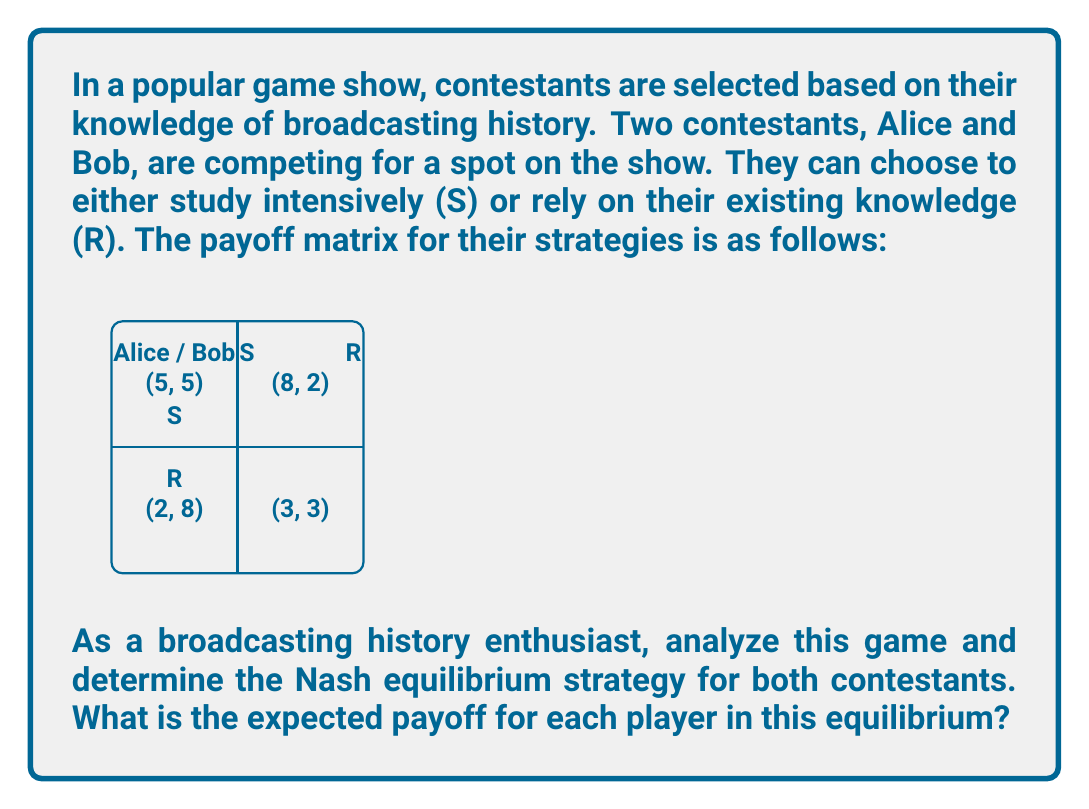Can you answer this question? To find the Nash equilibrium, we need to analyze each player's best response to the other player's strategy:

1. If Alice chooses S:
   - Bob's best response is R (payoff 8 > 5)
2. If Alice chooses R:
   - Bob's best response is S (payoff 8 > 3)
3. If Bob chooses S:
   - Alice's best response is R (payoff 8 > 5)
4. If Bob chooses R:
   - Alice's best response is S (payoff 8 > 3)

We can see that there is no pure strategy Nash equilibrium, as no pair of strategies is mutually best responses.

To find the mixed strategy Nash equilibrium:
Let $p$ be the probability that Alice chooses S, and $q$ be the probability that Bob chooses S.

For Alice to be indifferent:
$5q + 8(1-q) = 2q + 3(1-q)$
$5q + 8 - 8q = 2q + 3 - 3q$
$-3q + 8 = -q + 3$
$-2q = -5$
$q = \frac{5}{2} = 0.6$

For Bob to be indifferent:
$5p + 2(1-p) = 8p + 3(1-p)$
$5p + 2 - 2p = 8p + 3 - 3p$
$3p + 2 = 5p + 3$
$-2p = 1$
$p = \frac{1}{2} = 0.5$

The Nash equilibrium is for Alice to choose S with probability 0.5 and Bob to choose S with probability 0.6.

Expected payoff for Alice:
$E_A = 5(0.5)(0.6) + 8(0.5)(0.4) + 2(0.5)(0.6) + 3(0.5)(0.4) = 4.5$

Expected payoff for Bob:
$E_B = 5(0.6)(0.5) + 2(0.6)(0.5) + 8(0.4)(0.5) + 3(0.4)(0.5) = 4.5$
Answer: Mixed strategy Nash equilibrium: Alice (0.5 S, 0.5 R), Bob (0.6 S, 0.4 R). Expected payoff for each: 4.5. 